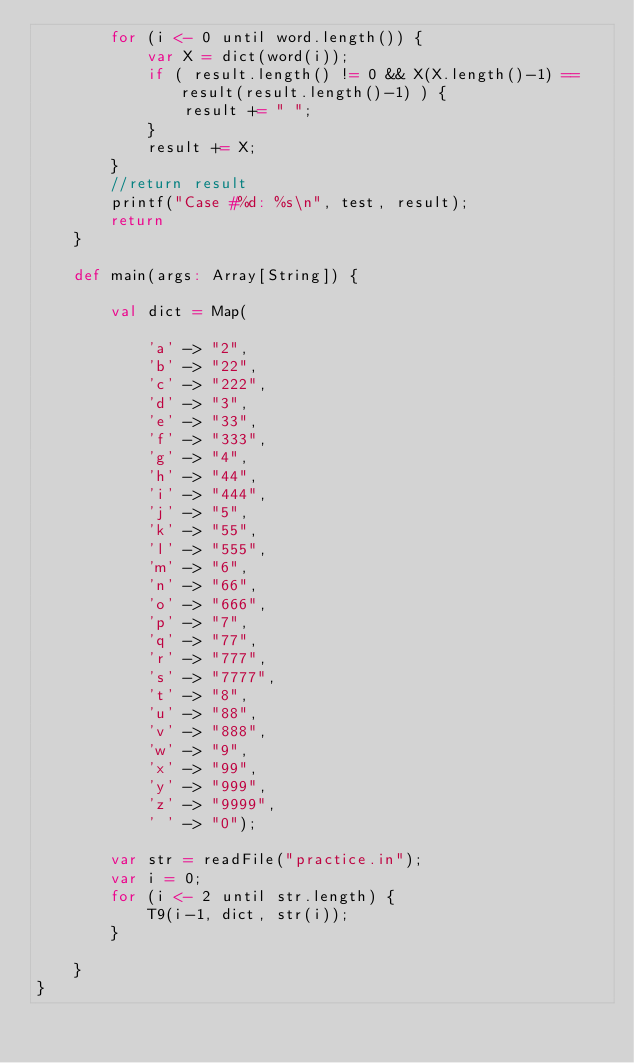Convert code to text. <code><loc_0><loc_0><loc_500><loc_500><_Scala_>		for (i <- 0 until word.length()) {
			var X = dict(word(i));
			if ( result.length() != 0 && X(X.length()-1) == result(result.length()-1) ) {
				result += " ";
			}
			result += X;
		}
		//return result
	    printf("Case #%d: %s\n", test, result);
	    return 
	}
 
	def main(args: Array[String]) {
 
		val dict = Map(
 
			'a' -> "2",
			'b' -> "22",
			'c' -> "222",
			'd' -> "3",
			'e' -> "33",
			'f' -> "333",
			'g' -> "4",
			'h' -> "44",
			'i' -> "444",
			'j' -> "5",
			'k' -> "55",
			'l' -> "555",
			'm' -> "6",
			'n' -> "66",
			'o' -> "666",
			'p' -> "7",
			'q' -> "77",
			'r' -> "777",
			's' -> "7777",
			't' -> "8",
			'u' -> "88",
			'v' -> "888",
			'w' -> "9",
			'x' -> "99",
			'y' -> "999",
			'z' -> "9999",
			' ' -> "0");
 
		var str = readFile("practice.in");
		var i = 0;
		for (i <- 2 until str.length) {
			T9(i-1, dict, str(i));
		}
 
	}
}
</code> 